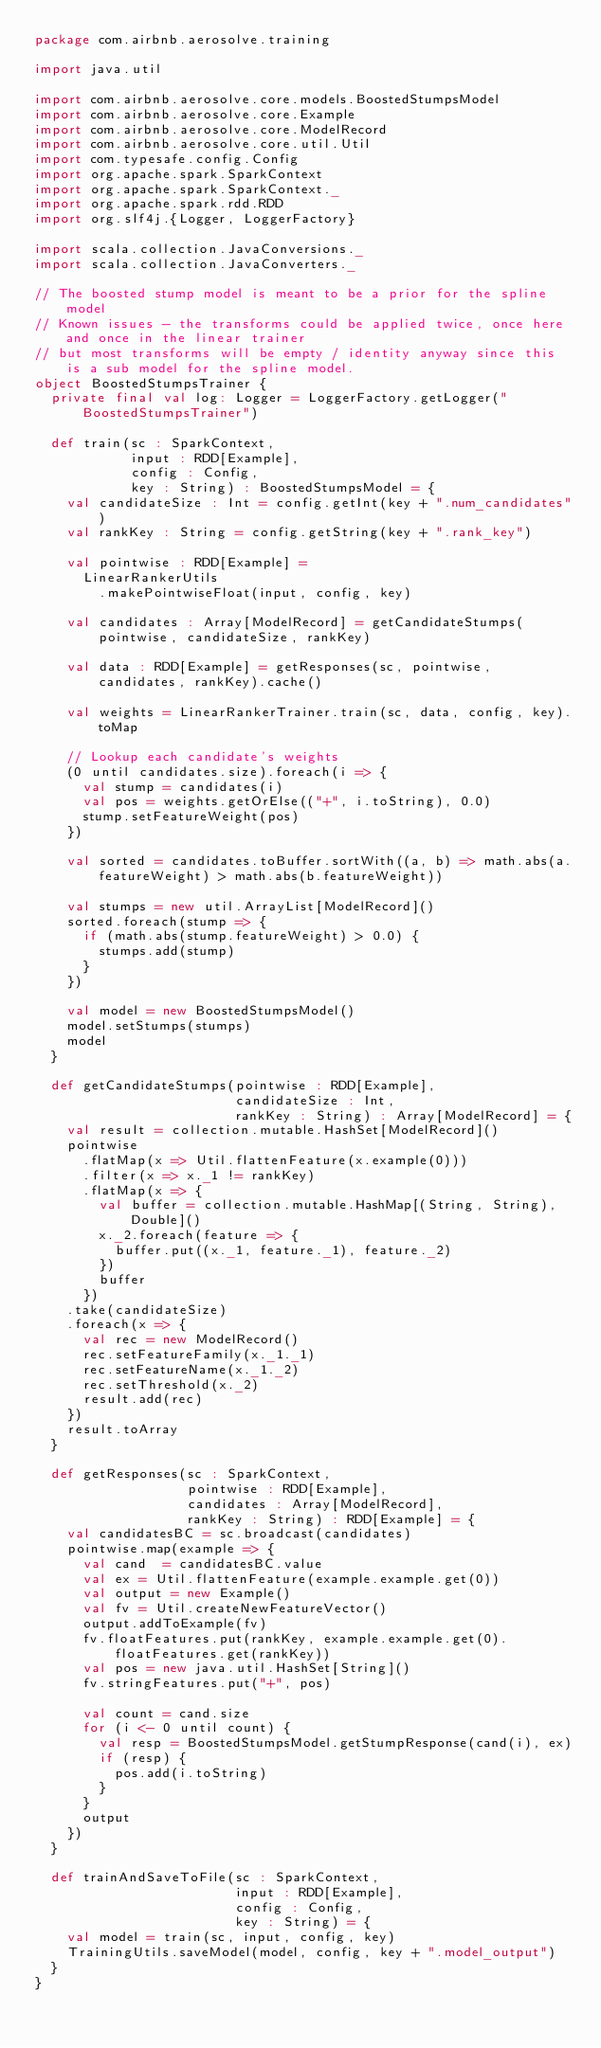<code> <loc_0><loc_0><loc_500><loc_500><_Scala_>package com.airbnb.aerosolve.training

import java.util

import com.airbnb.aerosolve.core.models.BoostedStumpsModel
import com.airbnb.aerosolve.core.Example
import com.airbnb.aerosolve.core.ModelRecord
import com.airbnb.aerosolve.core.util.Util
import com.typesafe.config.Config
import org.apache.spark.SparkContext
import org.apache.spark.SparkContext._
import org.apache.spark.rdd.RDD
import org.slf4j.{Logger, LoggerFactory}

import scala.collection.JavaConversions._
import scala.collection.JavaConverters._

// The boosted stump model is meant to be a prior for the spline model
// Known issues - the transforms could be applied twice, once here and once in the linear trainer
// but most transforms will be empty / identity anyway since this is a sub model for the spline model.
object BoostedStumpsTrainer {
  private final val log: Logger = LoggerFactory.getLogger("BoostedStumpsTrainer")

  def train(sc : SparkContext,
            input : RDD[Example],
            config : Config,
            key : String) : BoostedStumpsModel = {
    val candidateSize : Int = config.getInt(key + ".num_candidates")
    val rankKey : String = config.getString(key + ".rank_key")

    val pointwise : RDD[Example] =
      LinearRankerUtils
        .makePointwiseFloat(input, config, key)

    val candidates : Array[ModelRecord] = getCandidateStumps(pointwise, candidateSize, rankKey)

    val data : RDD[Example] = getResponses(sc, pointwise, candidates, rankKey).cache()

    val weights = LinearRankerTrainer.train(sc, data, config, key).toMap

    // Lookup each candidate's weights
    (0 until candidates.size).foreach(i => {
      val stump = candidates(i)
      val pos = weights.getOrElse(("+", i.toString), 0.0)
      stump.setFeatureWeight(pos)
    })

    val sorted = candidates.toBuffer.sortWith((a, b) => math.abs(a.featureWeight) > math.abs(b.featureWeight))

    val stumps = new util.ArrayList[ModelRecord]()
    sorted.foreach(stump => {
      if (math.abs(stump.featureWeight) > 0.0) {
        stumps.add(stump)
      }
    })

    val model = new BoostedStumpsModel()
    model.setStumps(stumps)
    model
  }

  def getCandidateStumps(pointwise : RDD[Example],
                         candidateSize : Int,
                         rankKey : String) : Array[ModelRecord] = {
    val result = collection.mutable.HashSet[ModelRecord]()
    pointwise
      .flatMap(x => Util.flattenFeature(x.example(0)))
      .filter(x => x._1 != rankKey)
      .flatMap(x => {
        val buffer = collection.mutable.HashMap[(String, String), Double]()
        x._2.foreach(feature => {
          buffer.put((x._1, feature._1), feature._2)
        })
        buffer
      })
    .take(candidateSize)
    .foreach(x => {
      val rec = new ModelRecord()
      rec.setFeatureFamily(x._1._1)
      rec.setFeatureName(x._1._2)
      rec.setThreshold(x._2)
      result.add(rec)
    })
    result.toArray
  }

  def getResponses(sc : SparkContext,
                   pointwise : RDD[Example],
                   candidates : Array[ModelRecord],
                   rankKey : String) : RDD[Example] = {
    val candidatesBC = sc.broadcast(candidates)
    pointwise.map(example => {
      val cand  = candidatesBC.value
      val ex = Util.flattenFeature(example.example.get(0))
      val output = new Example()
      val fv = Util.createNewFeatureVector()
      output.addToExample(fv)
      fv.floatFeatures.put(rankKey, example.example.get(0).floatFeatures.get(rankKey))
      val pos = new java.util.HashSet[String]()
      fv.stringFeatures.put("+", pos)

      val count = cand.size
      for (i <- 0 until count) {
        val resp = BoostedStumpsModel.getStumpResponse(cand(i), ex)
        if (resp) {
          pos.add(i.toString)
        }
      }
      output
    })
  }

  def trainAndSaveToFile(sc : SparkContext,
                         input : RDD[Example],
                         config : Config,
                         key : String) = {
    val model = train(sc, input, config, key)
    TrainingUtils.saveModel(model, config, key + ".model_output")
  }
}
</code> 